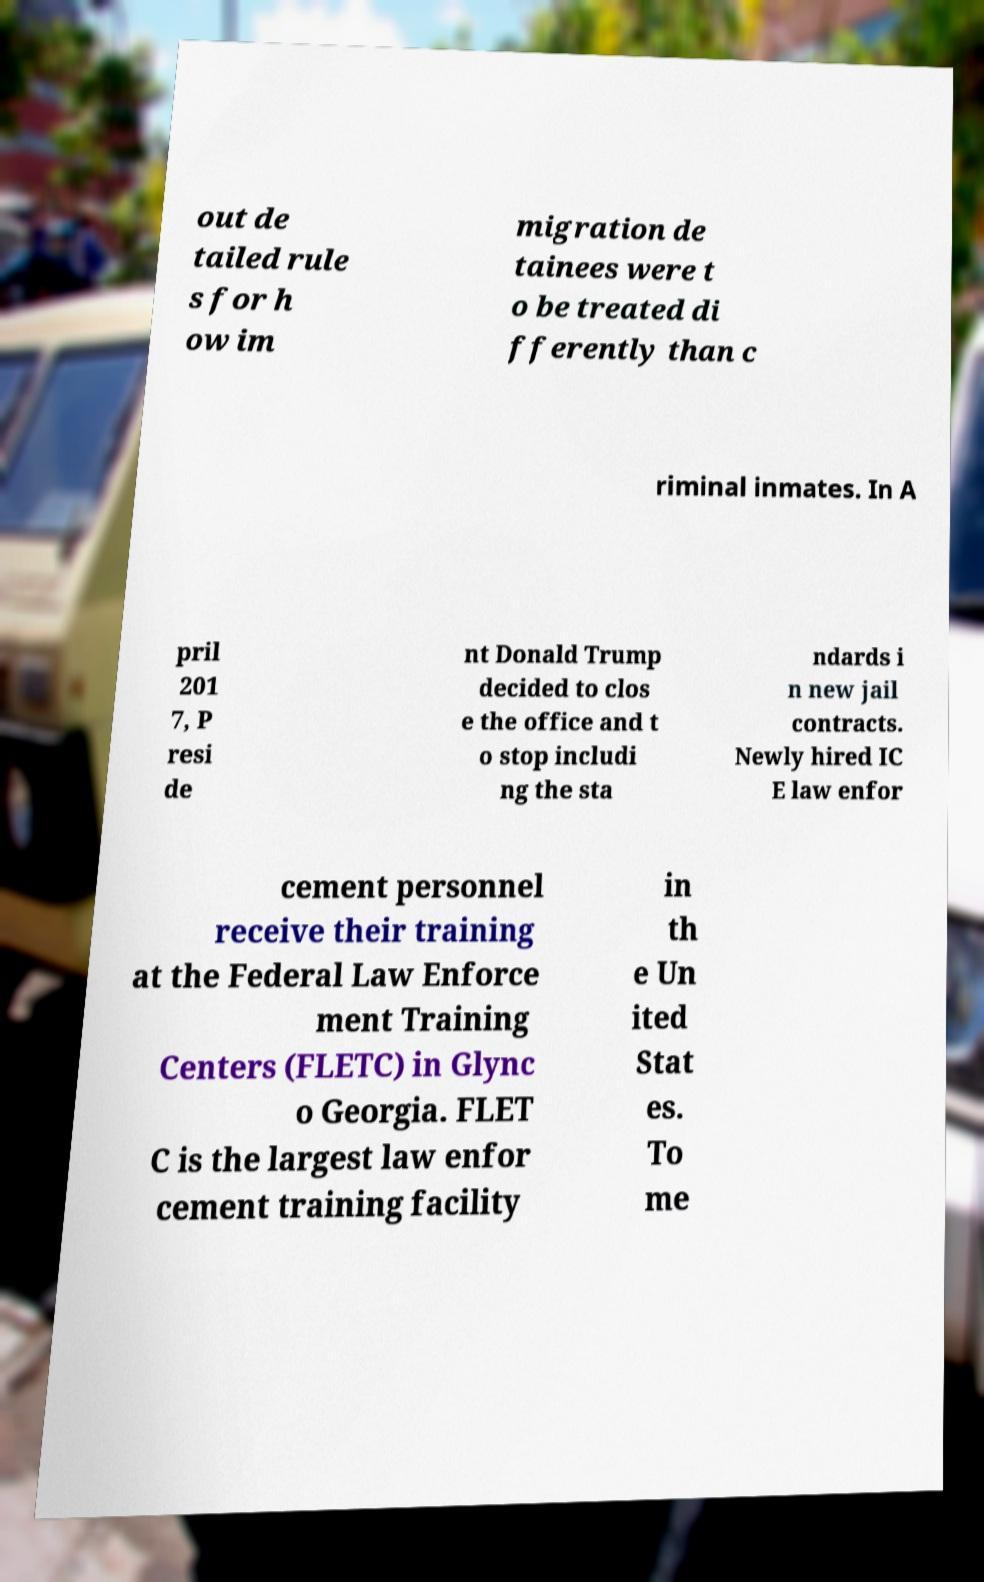Can you accurately transcribe the text from the provided image for me? out de tailed rule s for h ow im migration de tainees were t o be treated di fferently than c riminal inmates. In A pril 201 7, P resi de nt Donald Trump decided to clos e the office and t o stop includi ng the sta ndards i n new jail contracts. Newly hired IC E law enfor cement personnel receive their training at the Federal Law Enforce ment Training Centers (FLETC) in Glync o Georgia. FLET C is the largest law enfor cement training facility in th e Un ited Stat es. To me 